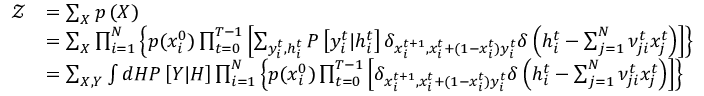<formula> <loc_0><loc_0><loc_500><loc_500>\begin{array} { r l } { \mathcal { Z } } & { = \sum _ { X } p \left ( X \right ) } \\ & { = \sum _ { X } \prod _ { i = 1 } ^ { N } \left \{ p ( x _ { i } ^ { 0 } ) \prod _ { t = 0 } ^ { T - 1 } \left [ \sum _ { y _ { i } ^ { t } , h _ { i } ^ { t } } P \left [ y _ { i } ^ { t } | h _ { i } ^ { t } \right ] \delta _ { x _ { i } ^ { t + 1 } , x _ { i } ^ { t } + ( 1 - x _ { i } ^ { t } ) y _ { i } ^ { t } } \delta \left ( h _ { i } ^ { t } - \sum _ { j = 1 } ^ { N } \nu _ { j i } ^ { t } x _ { j } ^ { t } \right ) \right ] \right \} } \\ & { = \sum _ { X , Y } \int d H P \left [ Y | H \right ] \prod _ { i = 1 } ^ { N } \left \{ p ( x _ { i } ^ { 0 } ) \prod _ { t = 0 } ^ { T - 1 } \left [ \delta _ { x _ { i } ^ { t + 1 } , x _ { i } ^ { t } + ( 1 - x _ { i } ^ { t } ) y _ { i } ^ { t } } \delta \left ( h _ { i } ^ { t } - \sum _ { j = 1 } ^ { N } \nu _ { j i } ^ { t } x _ { j } ^ { t } \right ) \right ] \right \} } \end{array}</formula> 